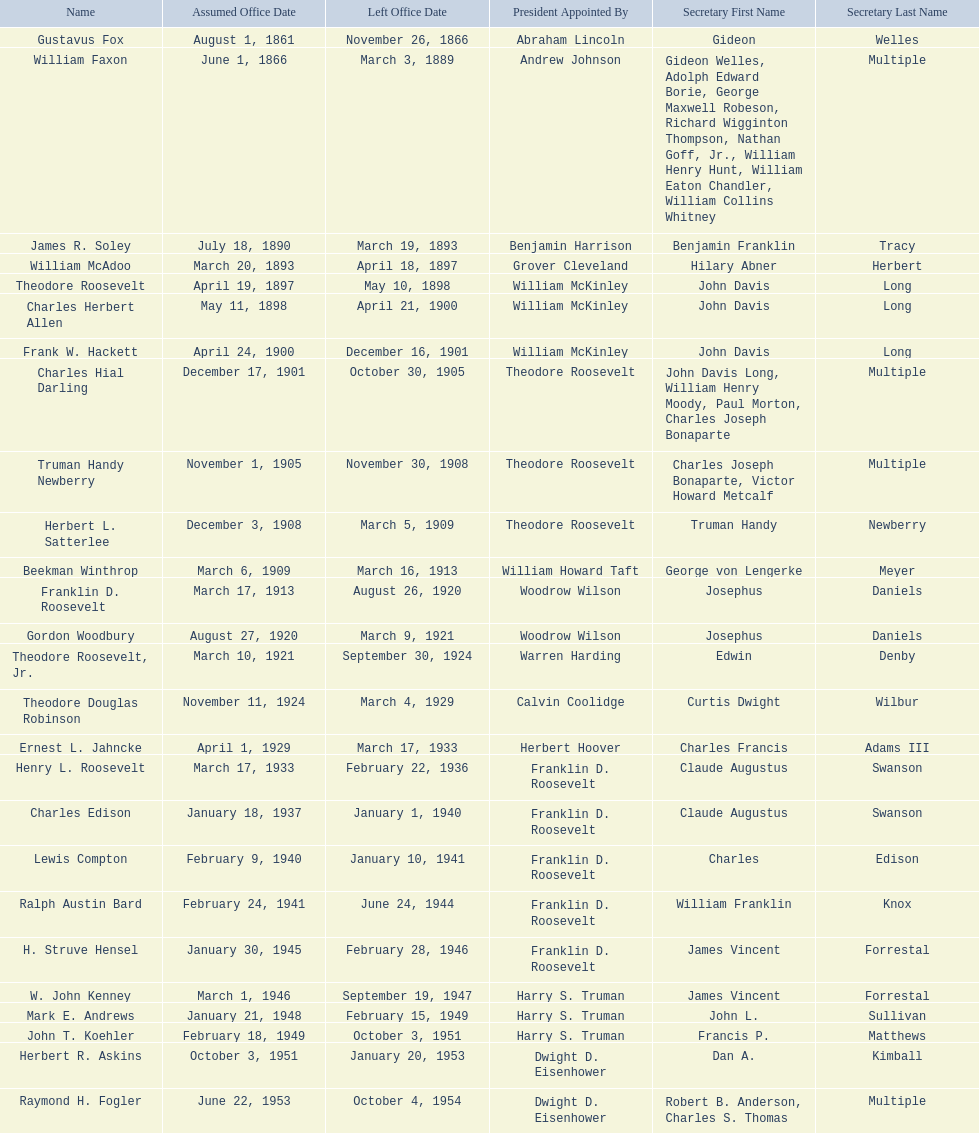What are all the names? Gustavus Fox, William Faxon, James R. Soley, William McAdoo, Theodore Roosevelt, Charles Herbert Allen, Frank W. Hackett, Charles Hial Darling, Truman Handy Newberry, Herbert L. Satterlee, Beekman Winthrop, Franklin D. Roosevelt, Gordon Woodbury, Theodore Roosevelt, Jr., Theodore Douglas Robinson, Ernest L. Jahncke, Henry L. Roosevelt, Charles Edison, Lewis Compton, Ralph Austin Bard, H. Struve Hensel, W. John Kenney, Mark E. Andrews, John T. Koehler, Herbert R. Askins, Raymond H. Fogler. When did they leave office? November 26, 1866, March 3, 1889, March 19, 1893, April 18, 1897, May 10, 1898, April 21, 1900, December 16, 1901, October 30, 1905, November 30, 1908, March 5, 1909, March 16, 1913, August 26, 1920, March 9, 1921, September 30, 1924, March 4, 1929, March 17, 1933, February 22, 1936, January 1, 1940, January 10, 1941, June 24, 1944, February 28, 1946, September 19, 1947, February 15, 1949, October 3, 1951, January 20, 1953, October 4, 1954. And when did raymond h. fogler leave? October 4, 1954. 